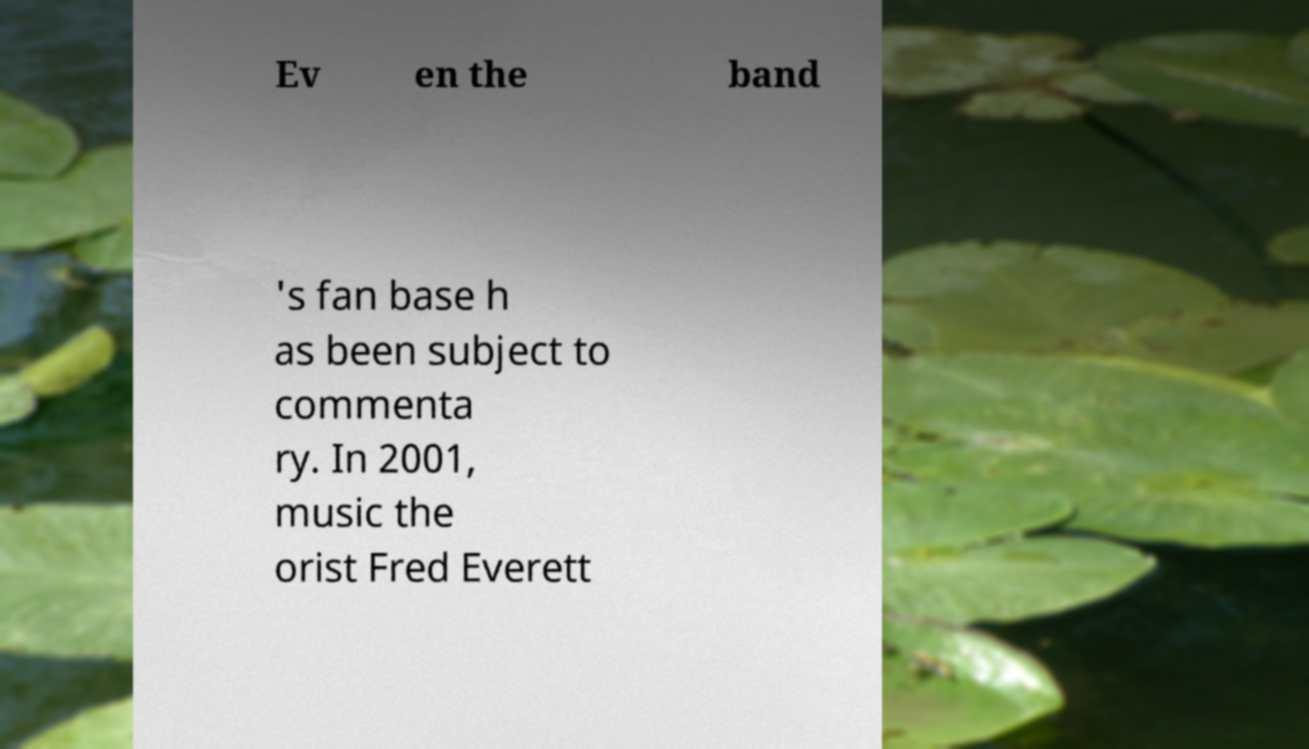I need the written content from this picture converted into text. Can you do that? Ev en the band 's fan base h as been subject to commenta ry. In 2001, music the orist Fred Everett 